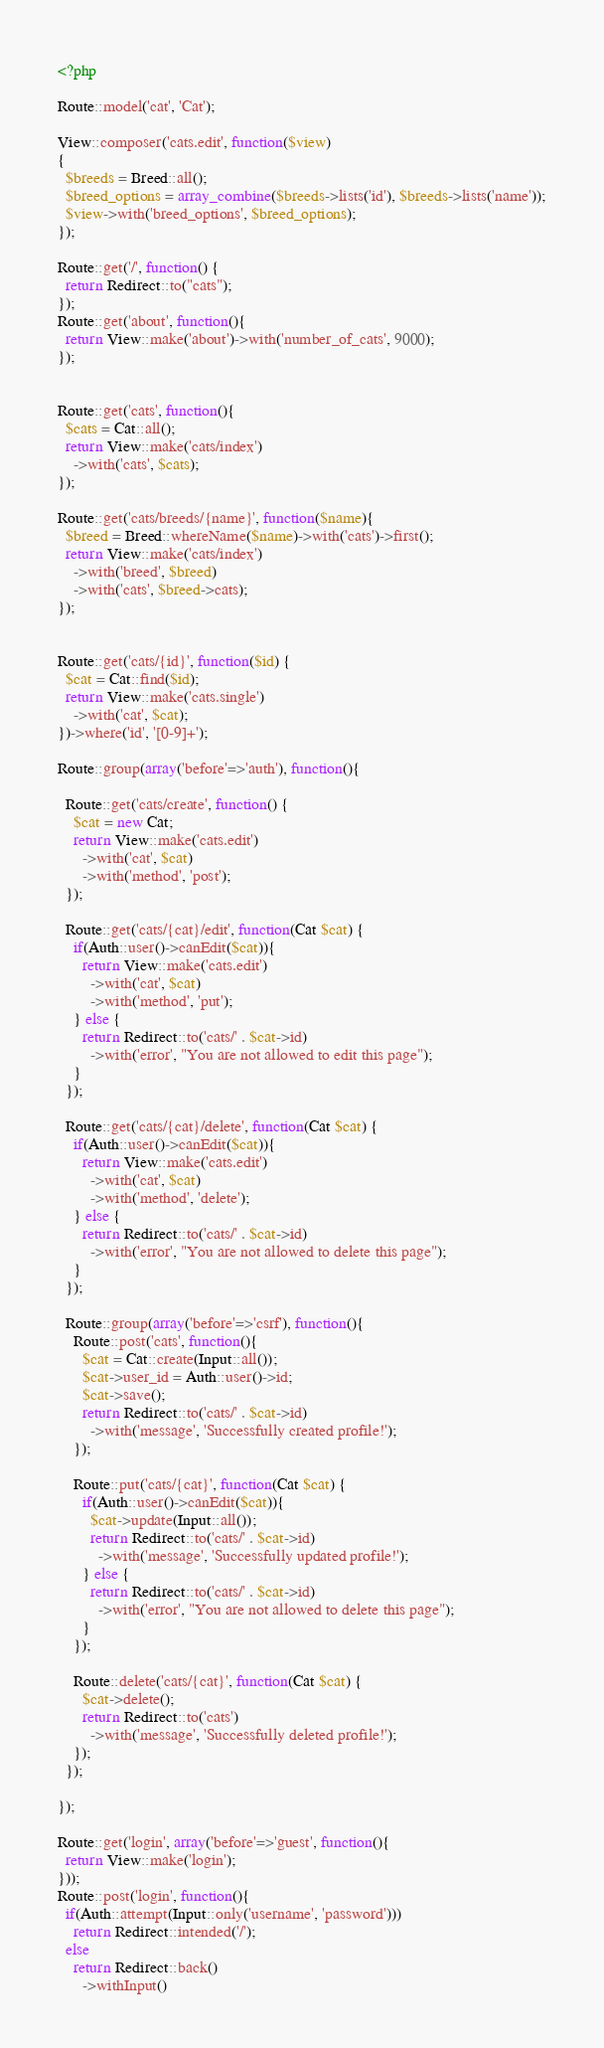Convert code to text. <code><loc_0><loc_0><loc_500><loc_500><_PHP_><?php

Route::model('cat', 'Cat');

View::composer('cats.edit', function($view)
{
  $breeds = Breed::all();
  $breed_options = array_combine($breeds->lists('id'), $breeds->lists('name'));
  $view->with('breed_options', $breed_options);
});

Route::get('/', function() {
  return Redirect::to("cats");
});
Route::get('about', function(){
  return View::make('about')->with('number_of_cats', 9000);
});


Route::get('cats', function(){
  $cats = Cat::all();
  return View::make('cats/index')
    ->with('cats', $cats);
});

Route::get('cats/breeds/{name}', function($name){
  $breed = Breed::whereName($name)->with('cats')->first();
  return View::make('cats/index')
    ->with('breed', $breed)
    ->with('cats', $breed->cats);
});


Route::get('cats/{id}', function($id) {
  $cat = Cat::find($id);
  return View::make('cats.single')
    ->with('cat', $cat);
})->where('id', '[0-9]+');

Route::group(array('before'=>'auth'), function(){

  Route::get('cats/create', function() {
    $cat = new Cat;
    return View::make('cats.edit')
      ->with('cat', $cat)
      ->with('method', 'post');
  });

  Route::get('cats/{cat}/edit', function(Cat $cat) {
    if(Auth::user()->canEdit($cat)){
      return View::make('cats.edit')
        ->with('cat', $cat)
        ->with('method', 'put');
    } else {
      return Redirect::to('cats/' . $cat->id)
        ->with('error', "You are not allowed to edit this page");
    }
  });

  Route::get('cats/{cat}/delete', function(Cat $cat) {
    if(Auth::user()->canEdit($cat)){
      return View::make('cats.edit')
        ->with('cat', $cat)
        ->with('method', 'delete');
    } else {
      return Redirect::to('cats/' . $cat->id)
        ->with('error', "You are not allowed to delete this page");
    }
  });

  Route::group(array('before'=>'csrf'), function(){
    Route::post('cats', function(){
      $cat = Cat::create(Input::all());
      $cat->user_id = Auth::user()->id;
      $cat->save();
      return Redirect::to('cats/' . $cat->id)
        ->with('message', 'Successfully created profile!');
    });

    Route::put('cats/{cat}', function(Cat $cat) {
      if(Auth::user()->canEdit($cat)){
        $cat->update(Input::all());
        return Redirect::to('cats/' . $cat->id)
          ->with('message', 'Successfully updated profile!');
      } else {
        return Redirect::to('cats/' . $cat->id)
          ->with('error', "You are not allowed to delete this page");
      }
    });

    Route::delete('cats/{cat}', function(Cat $cat) {
      $cat->delete();
      return Redirect::to('cats')
        ->with('message', 'Successfully deleted profile!');
    });
  });

});

Route::get('login', array('before'=>'guest', function(){
  return View::make('login');
}));
Route::post('login', function(){
  if(Auth::attempt(Input::only('username', 'password')))
    return Redirect::intended('/');
  else
    return Redirect::back()
      ->withInput()</code> 